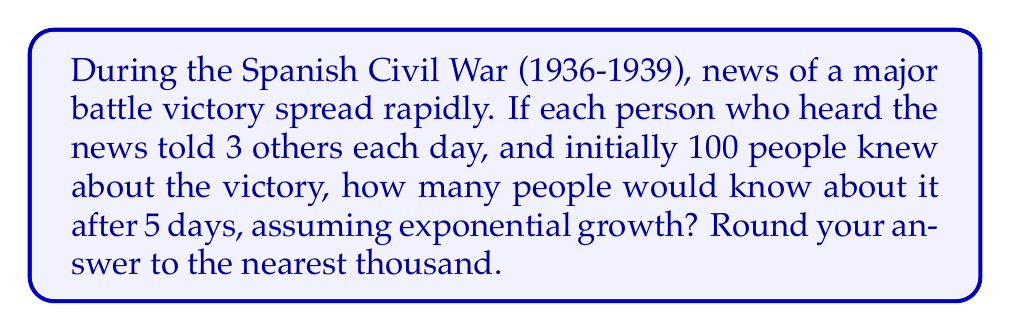Show me your answer to this math problem. Let's approach this step-by-step using an exponential growth equation:

1) The exponential growth equation is:
   $$P(t) = P_0 \cdot r^t$$
   Where:
   $P(t)$ is the final amount
   $P_0$ is the initial amount
   $r$ is the growth factor per unit time
   $t$ is the number of time units

2) In this case:
   $P_0 = 100$ (initial number of people)
   $r = 3$ (each person tells 3 others each day)
   $t = 5$ (number of days)

3) Plugging these values into the equation:
   $$P(5) = 100 \cdot 3^5$$

4) Calculate $3^5$:
   $$3^5 = 3 \cdot 3 \cdot 3 \cdot 3 \cdot 3 = 243$$

5) Multiply:
   $$P(5) = 100 \cdot 243 = 24,300$$

6) Rounding to the nearest thousand:
   24,300 rounds to 24,000

Therefore, after 5 days, approximately 24,000 people would know about the battle victory.
Answer: 24,000 people 